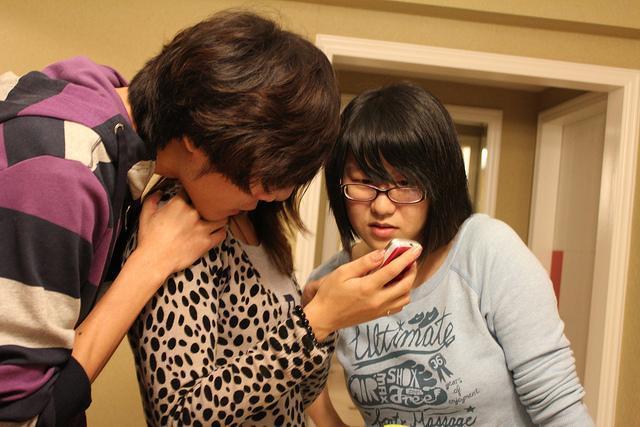How many faces can be seen?
Give a very brief answer. 2. How many people are visible?
Give a very brief answer. 3. 